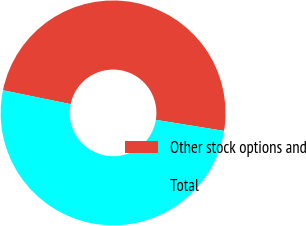Convert chart to OTSL. <chart><loc_0><loc_0><loc_500><loc_500><pie_chart><fcel>Other stock options and<fcel>Total<nl><fcel>49.33%<fcel>50.67%<nl></chart> 